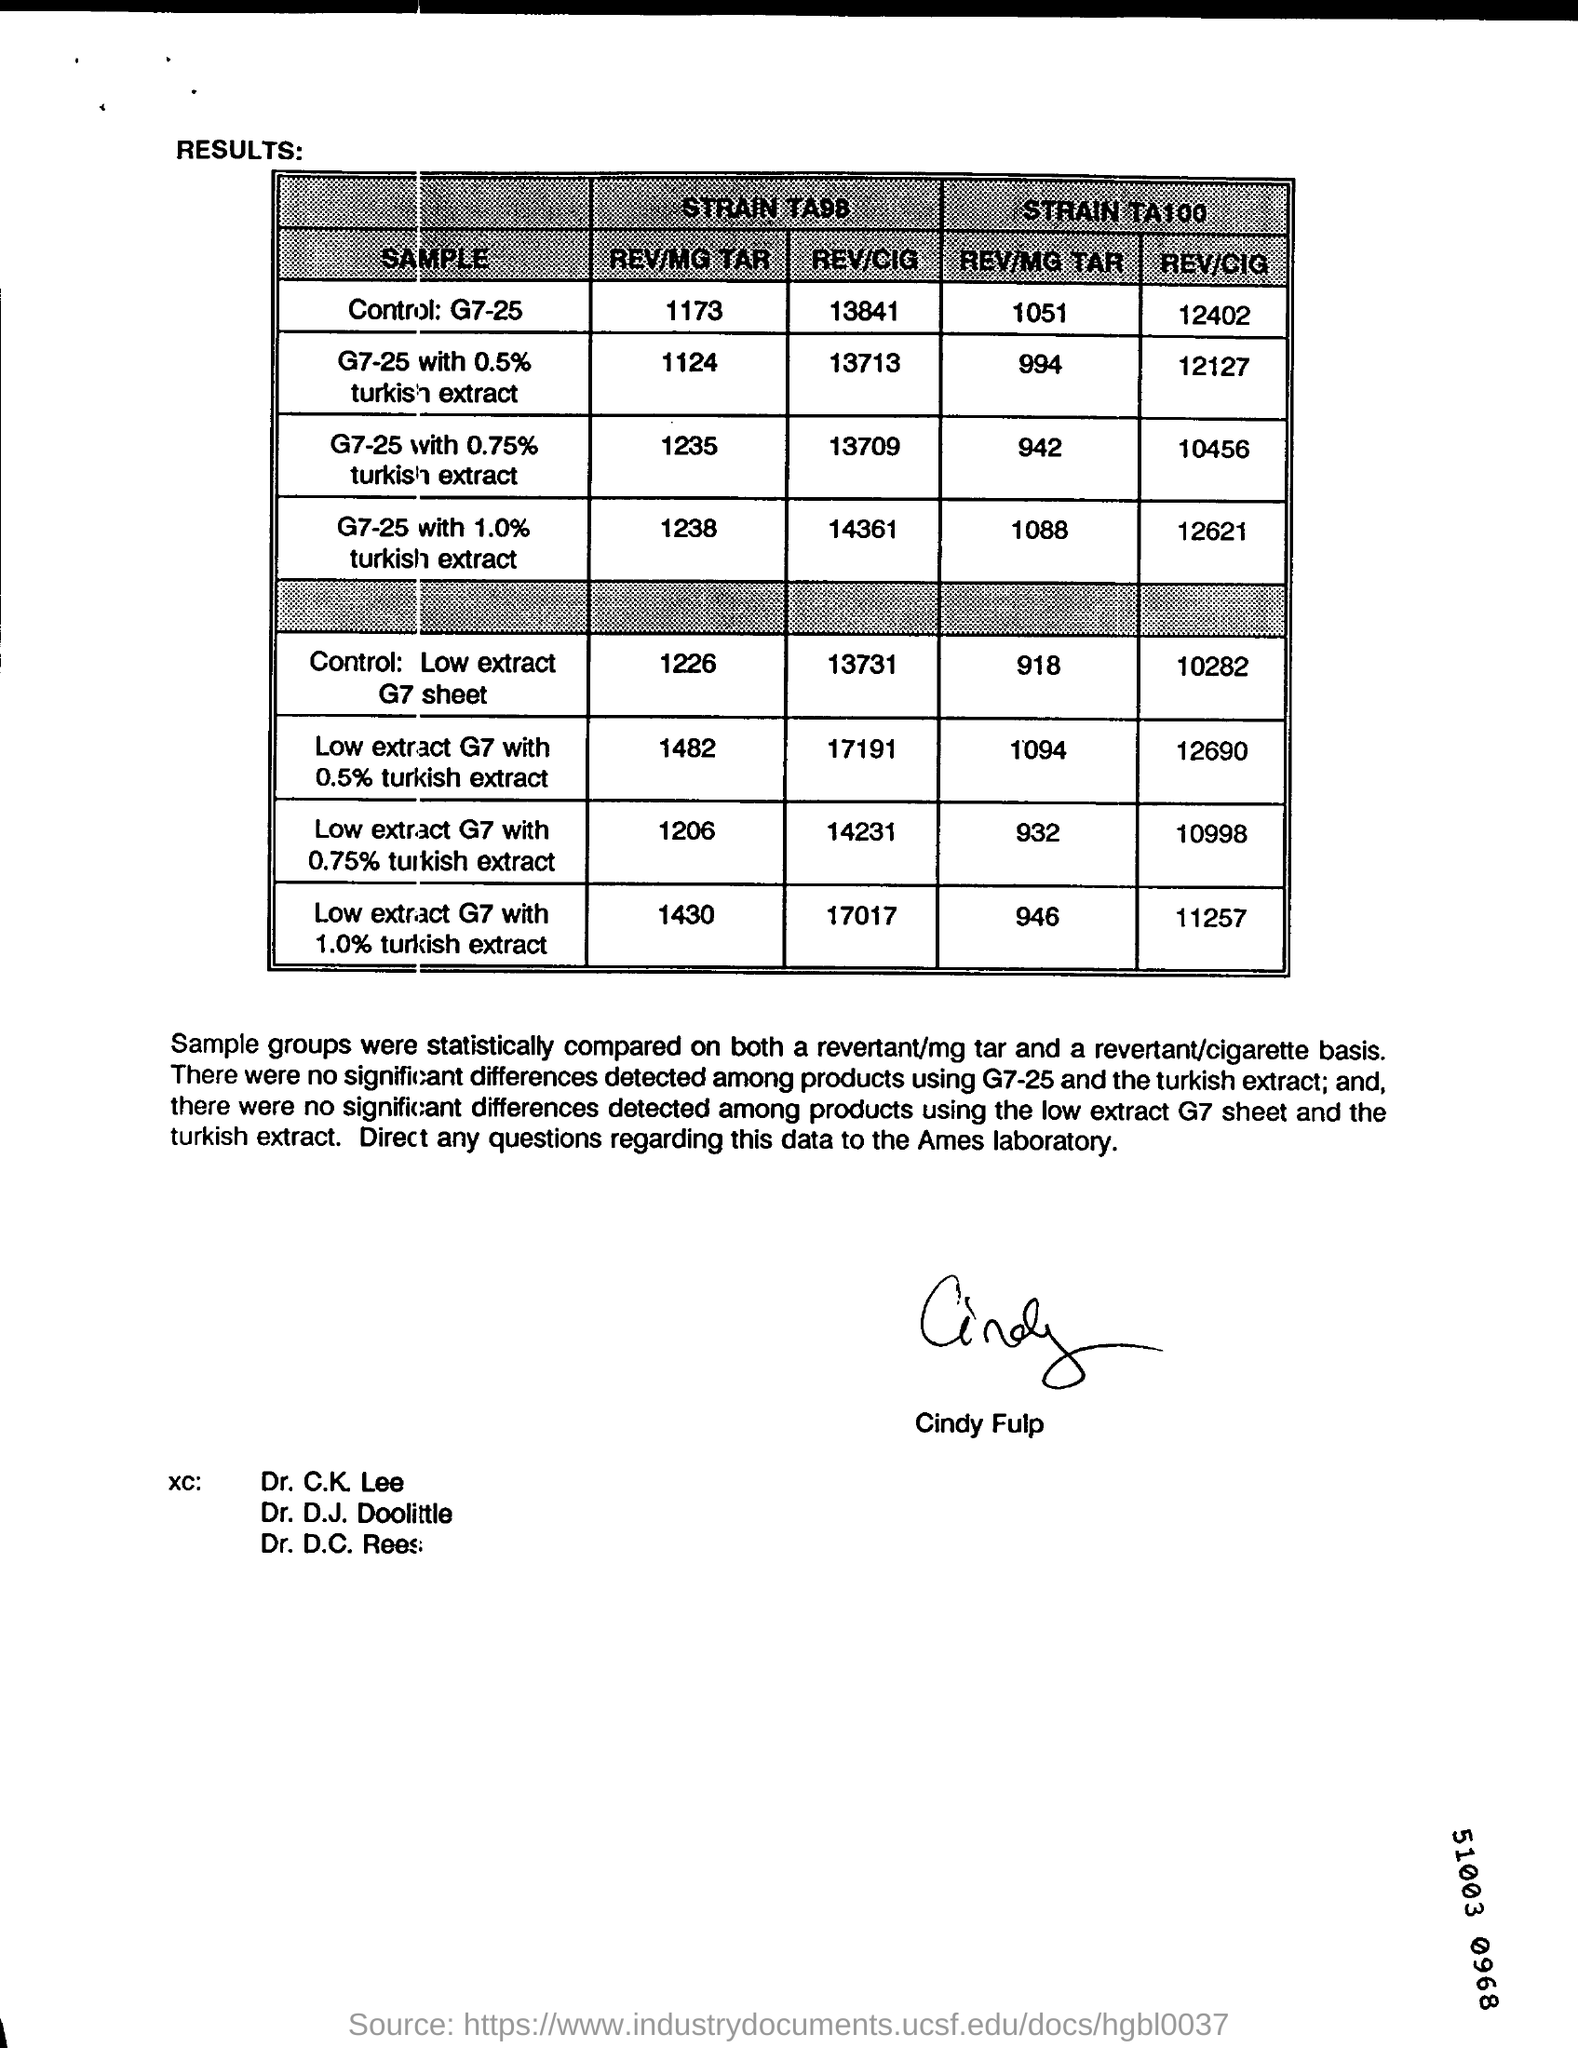What is the STRAIN TA100,REV/CIG of G7-25 with 1.0% turkish extract?
Offer a terse response. 12621. What is the sample of the STRAIN TA100, REV/MG TAR 1094?
Offer a very short reply. Low extract G7 with 0.5% turkish extract. 